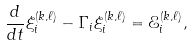Convert formula to latex. <formula><loc_0><loc_0><loc_500><loc_500>\frac { d } { d t } \xi ^ { ( k , \ell ) } _ { i } - \Gamma _ { i } \xi ^ { ( k , \ell ) } _ { i } = \mathcal { E } ^ { ( k , \ell ) } _ { i } ,</formula> 